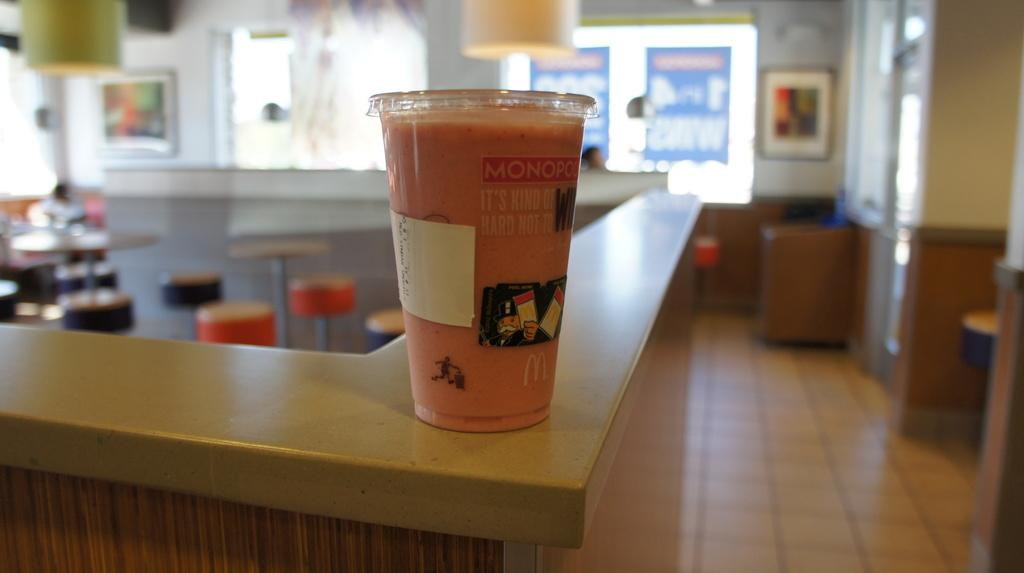What is in the glass that is visible in the image? There is a glass of drink in the image. What type of furniture can be seen in the image? There are tables and stools in the image. How would you describe the background of the image? The background is blurred. What type of ticket is visible on the table in the image? There is no ticket present in the image; only a glass of drink, tables, and stools are visible. 